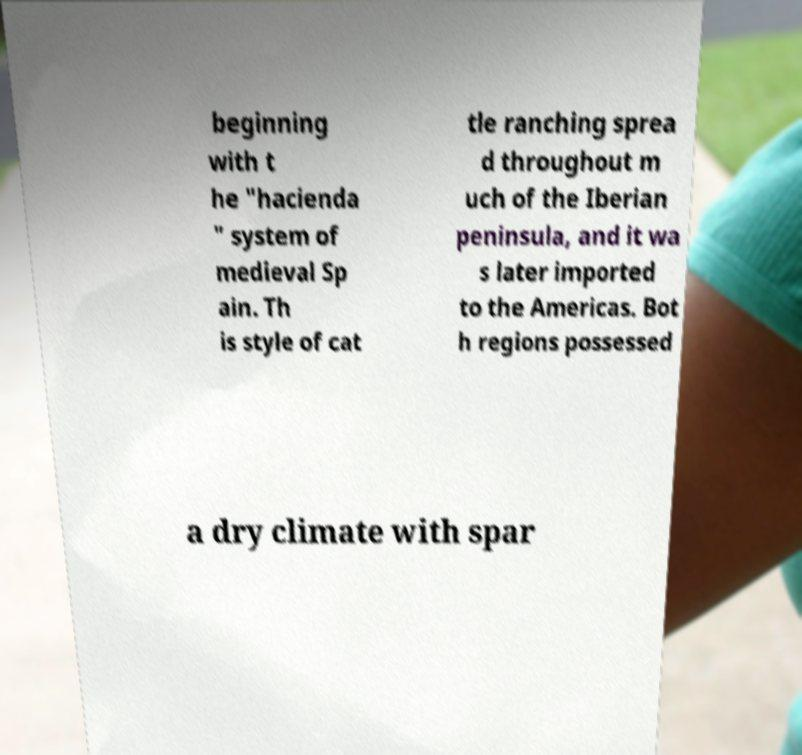Could you extract and type out the text from this image? beginning with t he "hacienda " system of medieval Sp ain. Th is style of cat tle ranching sprea d throughout m uch of the Iberian peninsula, and it wa s later imported to the Americas. Bot h regions possessed a dry climate with spar 